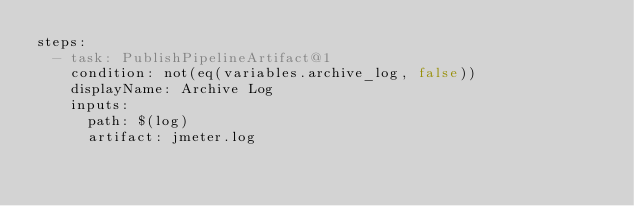<code> <loc_0><loc_0><loc_500><loc_500><_YAML_>steps:
  - task: PublishPipelineArtifact@1
    condition: not(eq(variables.archive_log, false))
    displayName: Archive Log
    inputs:
      path: $(log)
      artifact: jmeter.log</code> 